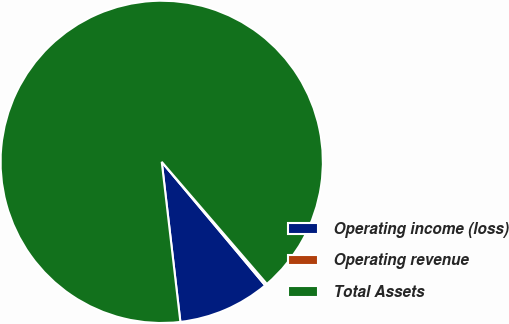Convert chart. <chart><loc_0><loc_0><loc_500><loc_500><pie_chart><fcel>Operating income (loss)<fcel>Operating revenue<fcel>Total Assets<nl><fcel>9.25%<fcel>0.22%<fcel>90.53%<nl></chart> 